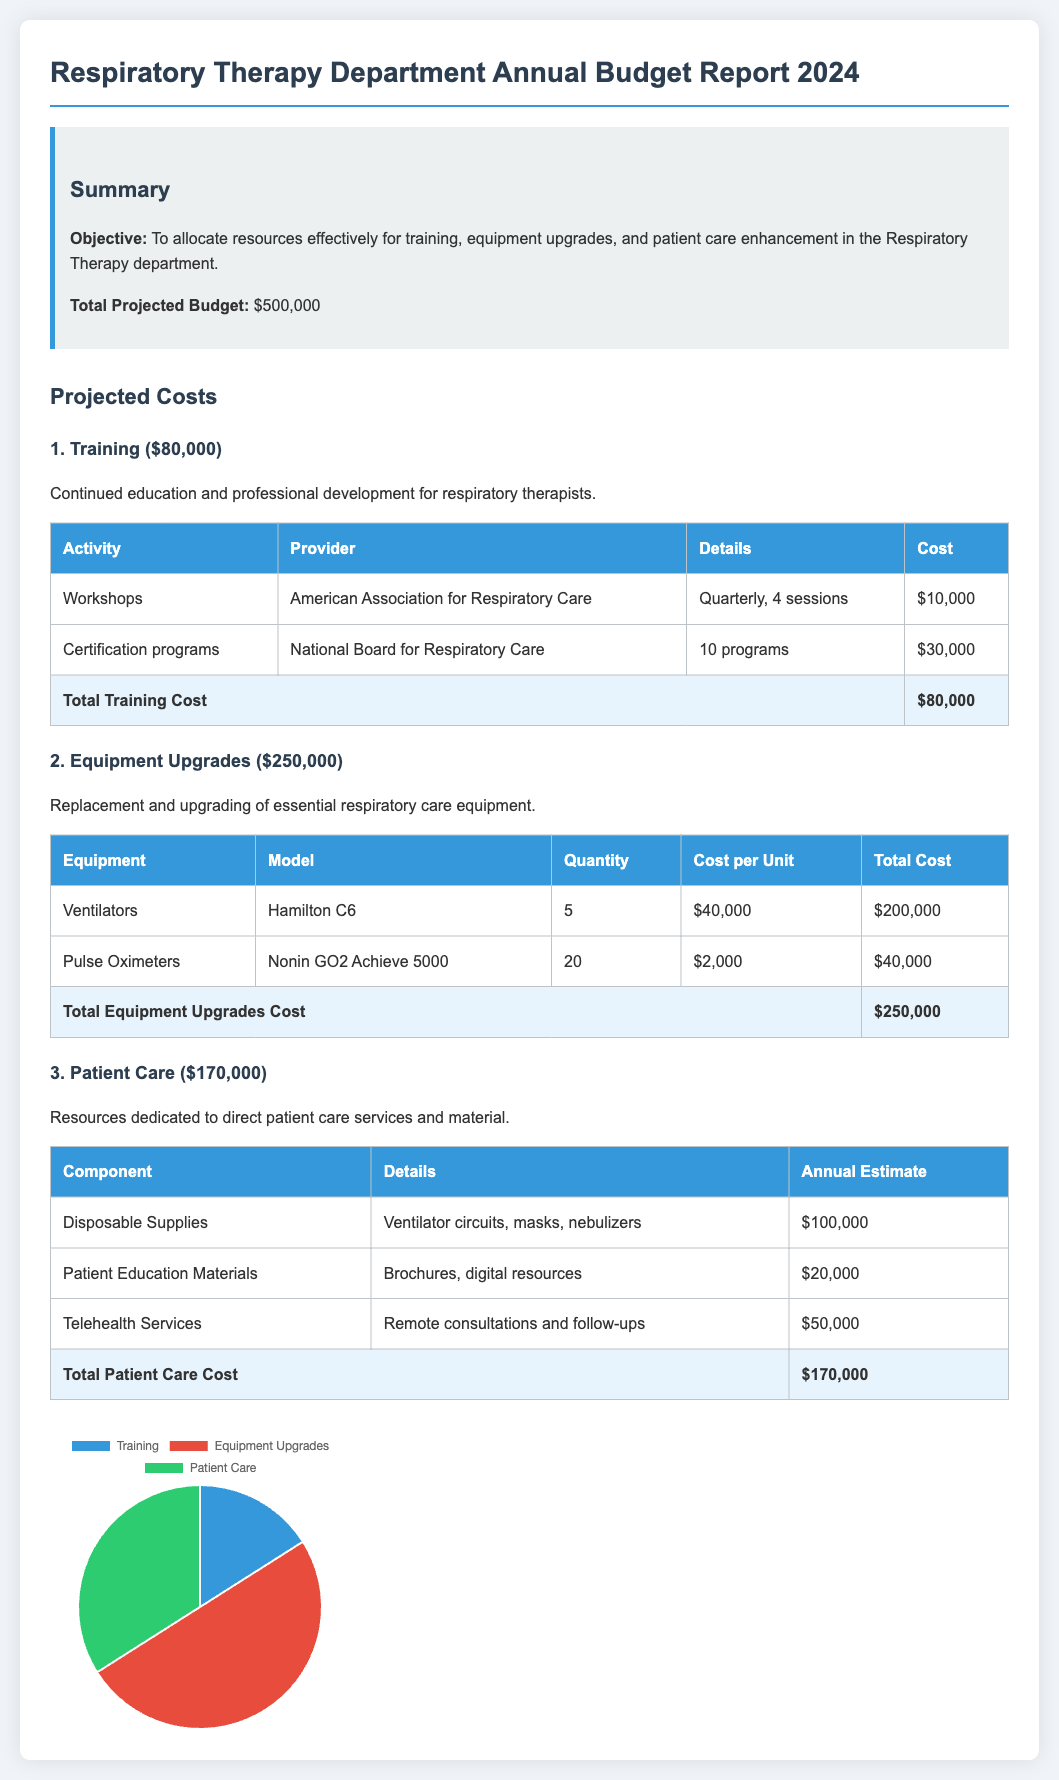What is the total projected budget? The total projected budget is clearly stated in the summary section of the document as $500,000.
Answer: $500,000 How much is allocated for training? The projected costs section breaks down the budget and assigns $80,000 to training activities.
Answer: $80,000 What is the cost of one Hamilton C6 ventilator? The equipment upgrades section specifies that the cost per unit for one Hamilton C6 ventilator is $40,000.
Answer: $40,000 What is the total cost for patient care? The total cost for patient care is listed in the projected costs section as $170,000.
Answer: $170,000 How many ventilators are planned for upgrade? The table under equipment upgrades shows that 5 ventilators are planned for upgrade.
Answer: 5 Which provider conducts the workshops? The document states that the American Association for Respiratory Care provides the workshops for training.
Answer: American Association for Respiratory Care What is the total cost for disposable supplies in patient care? The annual estimate for disposable supplies, such as ventilator circuits and masks, is mentioned as $100,000.
Answer: $100,000 Which equipment has the highest total cost in upgrades? The document indicates that the ventilators have the highest total cost at $200,000.
Answer: Ventilators What percentage of the total budget is allocated for equipment upgrades? The equipment upgrades budget of $250,000 is calculated as a percentage of the total projected budget of $500,000, resulting in 50%.
Answer: 50% 